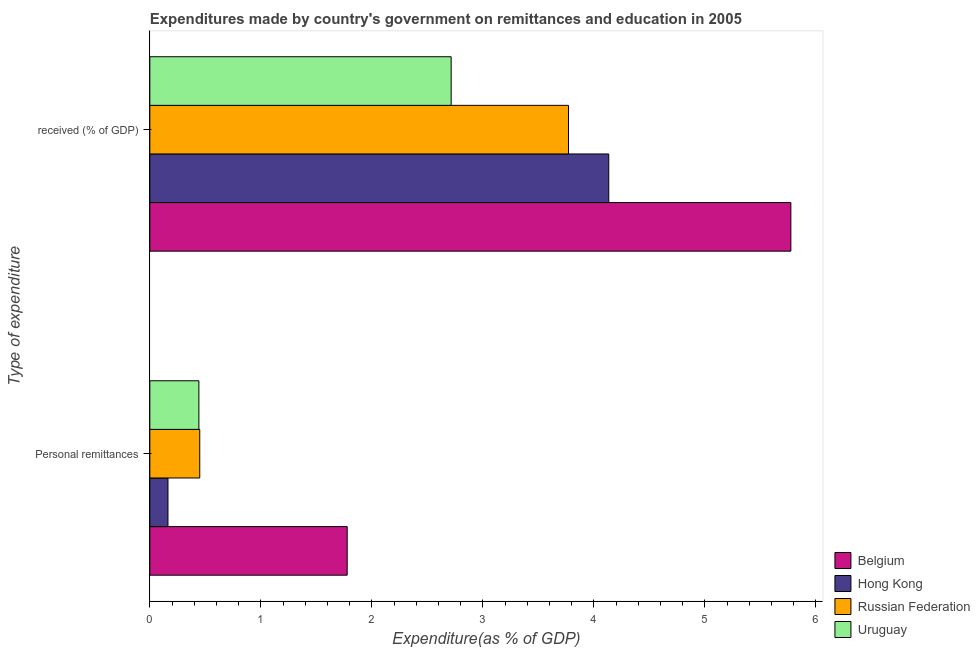How many groups of bars are there?
Give a very brief answer. 2. Are the number of bars per tick equal to the number of legend labels?
Provide a short and direct response. Yes. Are the number of bars on each tick of the Y-axis equal?
Make the answer very short. Yes. How many bars are there on the 1st tick from the top?
Make the answer very short. 4. How many bars are there on the 2nd tick from the bottom?
Offer a terse response. 4. What is the label of the 2nd group of bars from the top?
Your answer should be compact. Personal remittances. What is the expenditure in education in Belgium?
Your answer should be very brief. 5.78. Across all countries, what is the maximum expenditure in education?
Ensure brevity in your answer.  5.78. Across all countries, what is the minimum expenditure in personal remittances?
Offer a very short reply. 0.16. In which country was the expenditure in personal remittances minimum?
Your answer should be compact. Hong Kong. What is the total expenditure in education in the graph?
Make the answer very short. 16.4. What is the difference between the expenditure in personal remittances in Hong Kong and that in Uruguay?
Provide a succinct answer. -0.28. What is the difference between the expenditure in education in Uruguay and the expenditure in personal remittances in Hong Kong?
Your answer should be very brief. 2.55. What is the average expenditure in personal remittances per country?
Your answer should be compact. 0.71. What is the difference between the expenditure in education and expenditure in personal remittances in Belgium?
Make the answer very short. 4. What is the ratio of the expenditure in education in Russian Federation to that in Hong Kong?
Ensure brevity in your answer.  0.91. In how many countries, is the expenditure in personal remittances greater than the average expenditure in personal remittances taken over all countries?
Give a very brief answer. 1. What does the 1st bar from the top in  received (% of GDP) represents?
Your response must be concise. Uruguay. What does the 3rd bar from the bottom in Personal remittances represents?
Offer a very short reply. Russian Federation. How many bars are there?
Give a very brief answer. 8. How many countries are there in the graph?
Offer a terse response. 4. Are the values on the major ticks of X-axis written in scientific E-notation?
Ensure brevity in your answer.  No. Where does the legend appear in the graph?
Your answer should be very brief. Bottom right. What is the title of the graph?
Provide a succinct answer. Expenditures made by country's government on remittances and education in 2005. Does "Korea (Republic)" appear as one of the legend labels in the graph?
Provide a succinct answer. No. What is the label or title of the X-axis?
Your response must be concise. Expenditure(as % of GDP). What is the label or title of the Y-axis?
Provide a short and direct response. Type of expenditure. What is the Expenditure(as % of GDP) in Belgium in Personal remittances?
Keep it short and to the point. 1.78. What is the Expenditure(as % of GDP) of Hong Kong in Personal remittances?
Your answer should be compact. 0.16. What is the Expenditure(as % of GDP) of Russian Federation in Personal remittances?
Your response must be concise. 0.45. What is the Expenditure(as % of GDP) in Uruguay in Personal remittances?
Your answer should be very brief. 0.44. What is the Expenditure(as % of GDP) in Belgium in  received (% of GDP)?
Your answer should be very brief. 5.78. What is the Expenditure(as % of GDP) in Hong Kong in  received (% of GDP)?
Your answer should be very brief. 4.13. What is the Expenditure(as % of GDP) in Russian Federation in  received (% of GDP)?
Your response must be concise. 3.77. What is the Expenditure(as % of GDP) of Uruguay in  received (% of GDP)?
Keep it short and to the point. 2.71. Across all Type of expenditure, what is the maximum Expenditure(as % of GDP) in Belgium?
Offer a very short reply. 5.78. Across all Type of expenditure, what is the maximum Expenditure(as % of GDP) of Hong Kong?
Ensure brevity in your answer.  4.13. Across all Type of expenditure, what is the maximum Expenditure(as % of GDP) in Russian Federation?
Give a very brief answer. 3.77. Across all Type of expenditure, what is the maximum Expenditure(as % of GDP) in Uruguay?
Offer a very short reply. 2.71. Across all Type of expenditure, what is the minimum Expenditure(as % of GDP) of Belgium?
Your answer should be very brief. 1.78. Across all Type of expenditure, what is the minimum Expenditure(as % of GDP) of Hong Kong?
Your answer should be very brief. 0.16. Across all Type of expenditure, what is the minimum Expenditure(as % of GDP) in Russian Federation?
Ensure brevity in your answer.  0.45. Across all Type of expenditure, what is the minimum Expenditure(as % of GDP) of Uruguay?
Your answer should be very brief. 0.44. What is the total Expenditure(as % of GDP) in Belgium in the graph?
Give a very brief answer. 7.55. What is the total Expenditure(as % of GDP) in Hong Kong in the graph?
Your answer should be compact. 4.3. What is the total Expenditure(as % of GDP) in Russian Federation in the graph?
Offer a terse response. 4.22. What is the total Expenditure(as % of GDP) of Uruguay in the graph?
Give a very brief answer. 3.16. What is the difference between the Expenditure(as % of GDP) in Belgium in Personal remittances and that in  received (% of GDP)?
Your answer should be very brief. -4. What is the difference between the Expenditure(as % of GDP) in Hong Kong in Personal remittances and that in  received (% of GDP)?
Your answer should be very brief. -3.97. What is the difference between the Expenditure(as % of GDP) in Russian Federation in Personal remittances and that in  received (% of GDP)?
Keep it short and to the point. -3.32. What is the difference between the Expenditure(as % of GDP) in Uruguay in Personal remittances and that in  received (% of GDP)?
Offer a terse response. -2.27. What is the difference between the Expenditure(as % of GDP) in Belgium in Personal remittances and the Expenditure(as % of GDP) in Hong Kong in  received (% of GDP)?
Your answer should be compact. -2.36. What is the difference between the Expenditure(as % of GDP) of Belgium in Personal remittances and the Expenditure(as % of GDP) of Russian Federation in  received (% of GDP)?
Make the answer very short. -1.99. What is the difference between the Expenditure(as % of GDP) in Belgium in Personal remittances and the Expenditure(as % of GDP) in Uruguay in  received (% of GDP)?
Your answer should be very brief. -0.94. What is the difference between the Expenditure(as % of GDP) in Hong Kong in Personal remittances and the Expenditure(as % of GDP) in Russian Federation in  received (% of GDP)?
Provide a succinct answer. -3.61. What is the difference between the Expenditure(as % of GDP) of Hong Kong in Personal remittances and the Expenditure(as % of GDP) of Uruguay in  received (% of GDP)?
Offer a very short reply. -2.55. What is the difference between the Expenditure(as % of GDP) of Russian Federation in Personal remittances and the Expenditure(as % of GDP) of Uruguay in  received (% of GDP)?
Your answer should be very brief. -2.26. What is the average Expenditure(as % of GDP) of Belgium per Type of expenditure?
Your answer should be very brief. 3.78. What is the average Expenditure(as % of GDP) of Hong Kong per Type of expenditure?
Your answer should be compact. 2.15. What is the average Expenditure(as % of GDP) of Russian Federation per Type of expenditure?
Offer a very short reply. 2.11. What is the average Expenditure(as % of GDP) in Uruguay per Type of expenditure?
Make the answer very short. 1.58. What is the difference between the Expenditure(as % of GDP) in Belgium and Expenditure(as % of GDP) in Hong Kong in Personal remittances?
Make the answer very short. 1.61. What is the difference between the Expenditure(as % of GDP) of Belgium and Expenditure(as % of GDP) of Russian Federation in Personal remittances?
Your answer should be very brief. 1.33. What is the difference between the Expenditure(as % of GDP) of Belgium and Expenditure(as % of GDP) of Uruguay in Personal remittances?
Ensure brevity in your answer.  1.34. What is the difference between the Expenditure(as % of GDP) in Hong Kong and Expenditure(as % of GDP) in Russian Federation in Personal remittances?
Give a very brief answer. -0.29. What is the difference between the Expenditure(as % of GDP) of Hong Kong and Expenditure(as % of GDP) of Uruguay in Personal remittances?
Your answer should be very brief. -0.28. What is the difference between the Expenditure(as % of GDP) in Russian Federation and Expenditure(as % of GDP) in Uruguay in Personal remittances?
Your answer should be very brief. 0.01. What is the difference between the Expenditure(as % of GDP) of Belgium and Expenditure(as % of GDP) of Hong Kong in  received (% of GDP)?
Your answer should be compact. 1.64. What is the difference between the Expenditure(as % of GDP) of Belgium and Expenditure(as % of GDP) of Russian Federation in  received (% of GDP)?
Ensure brevity in your answer.  2. What is the difference between the Expenditure(as % of GDP) in Belgium and Expenditure(as % of GDP) in Uruguay in  received (% of GDP)?
Keep it short and to the point. 3.06. What is the difference between the Expenditure(as % of GDP) of Hong Kong and Expenditure(as % of GDP) of Russian Federation in  received (% of GDP)?
Offer a terse response. 0.36. What is the difference between the Expenditure(as % of GDP) in Hong Kong and Expenditure(as % of GDP) in Uruguay in  received (% of GDP)?
Make the answer very short. 1.42. What is the difference between the Expenditure(as % of GDP) of Russian Federation and Expenditure(as % of GDP) of Uruguay in  received (% of GDP)?
Offer a very short reply. 1.06. What is the ratio of the Expenditure(as % of GDP) of Belgium in Personal remittances to that in  received (% of GDP)?
Ensure brevity in your answer.  0.31. What is the ratio of the Expenditure(as % of GDP) in Hong Kong in Personal remittances to that in  received (% of GDP)?
Offer a terse response. 0.04. What is the ratio of the Expenditure(as % of GDP) in Russian Federation in Personal remittances to that in  received (% of GDP)?
Provide a succinct answer. 0.12. What is the ratio of the Expenditure(as % of GDP) in Uruguay in Personal remittances to that in  received (% of GDP)?
Ensure brevity in your answer.  0.16. What is the difference between the highest and the second highest Expenditure(as % of GDP) of Belgium?
Provide a succinct answer. 4. What is the difference between the highest and the second highest Expenditure(as % of GDP) of Hong Kong?
Provide a short and direct response. 3.97. What is the difference between the highest and the second highest Expenditure(as % of GDP) in Russian Federation?
Provide a succinct answer. 3.32. What is the difference between the highest and the second highest Expenditure(as % of GDP) of Uruguay?
Offer a very short reply. 2.27. What is the difference between the highest and the lowest Expenditure(as % of GDP) in Belgium?
Your answer should be very brief. 4. What is the difference between the highest and the lowest Expenditure(as % of GDP) in Hong Kong?
Offer a very short reply. 3.97. What is the difference between the highest and the lowest Expenditure(as % of GDP) of Russian Federation?
Provide a succinct answer. 3.32. What is the difference between the highest and the lowest Expenditure(as % of GDP) in Uruguay?
Give a very brief answer. 2.27. 